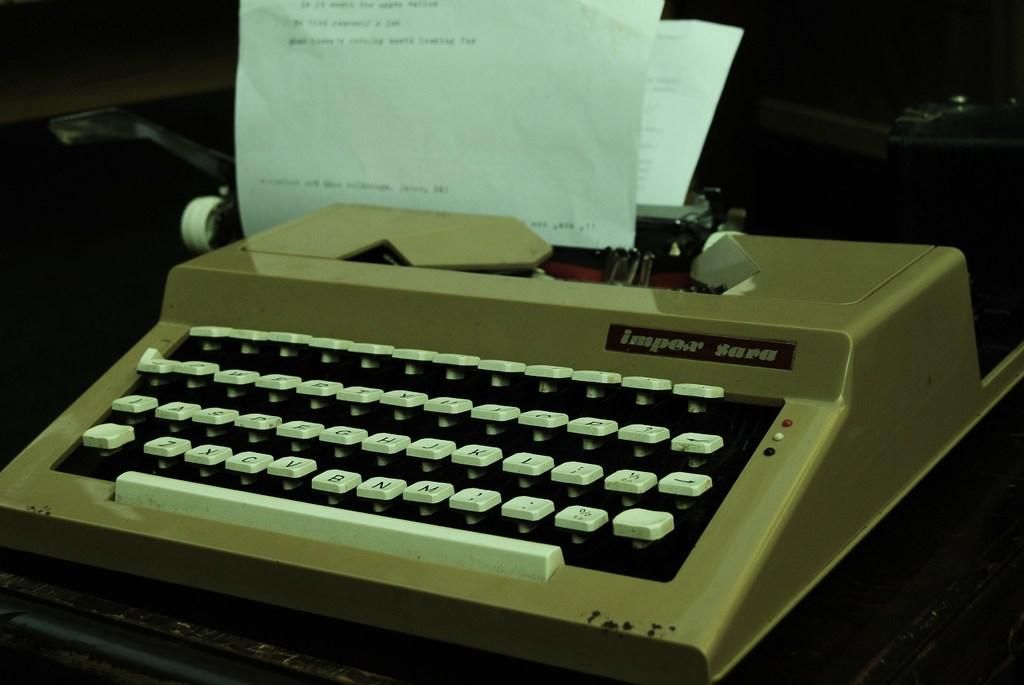What device is visible in the image? There is a printer in the image. What is present alongside the printer? There are papers in the image. Can you describe the unspecified object on the table in the image? Unfortunately, the facts provided do not give enough information to describe the unspecified object on the table. What type of expert advice can be heard from the donkey in the image? There is no donkey present in the image, so it is not possible to hear any expert advice from a donkey. 